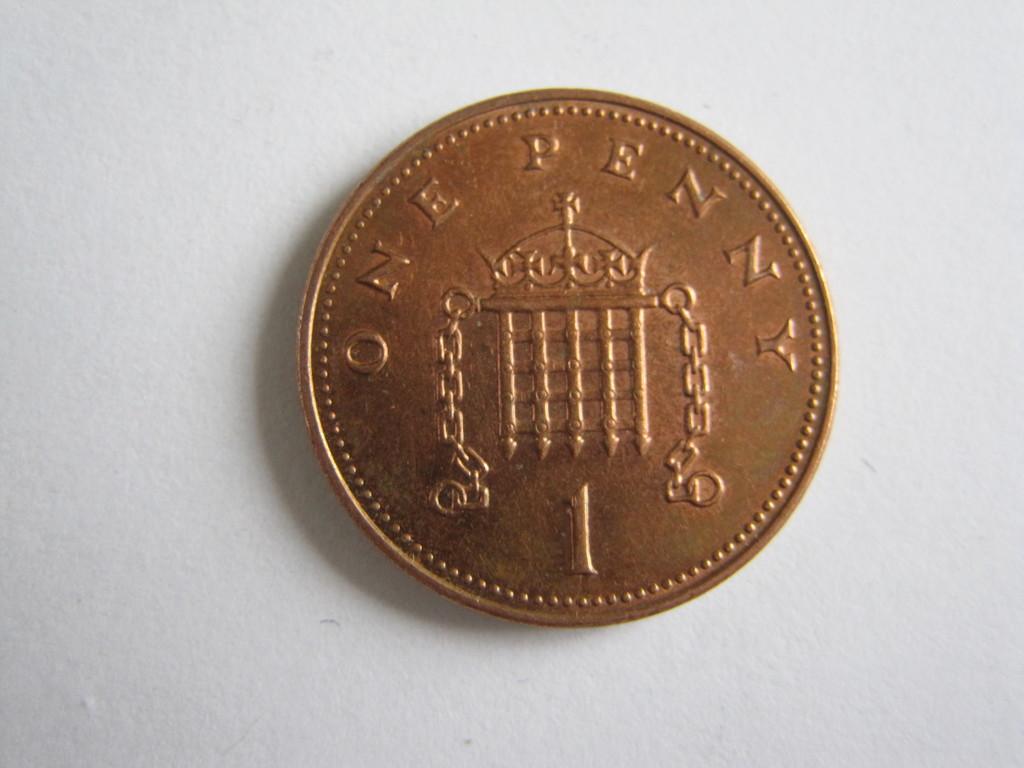How much is this coin worth?
Your answer should be compact. One penny. What is the number on the coiun?
Provide a succinct answer. 1. 